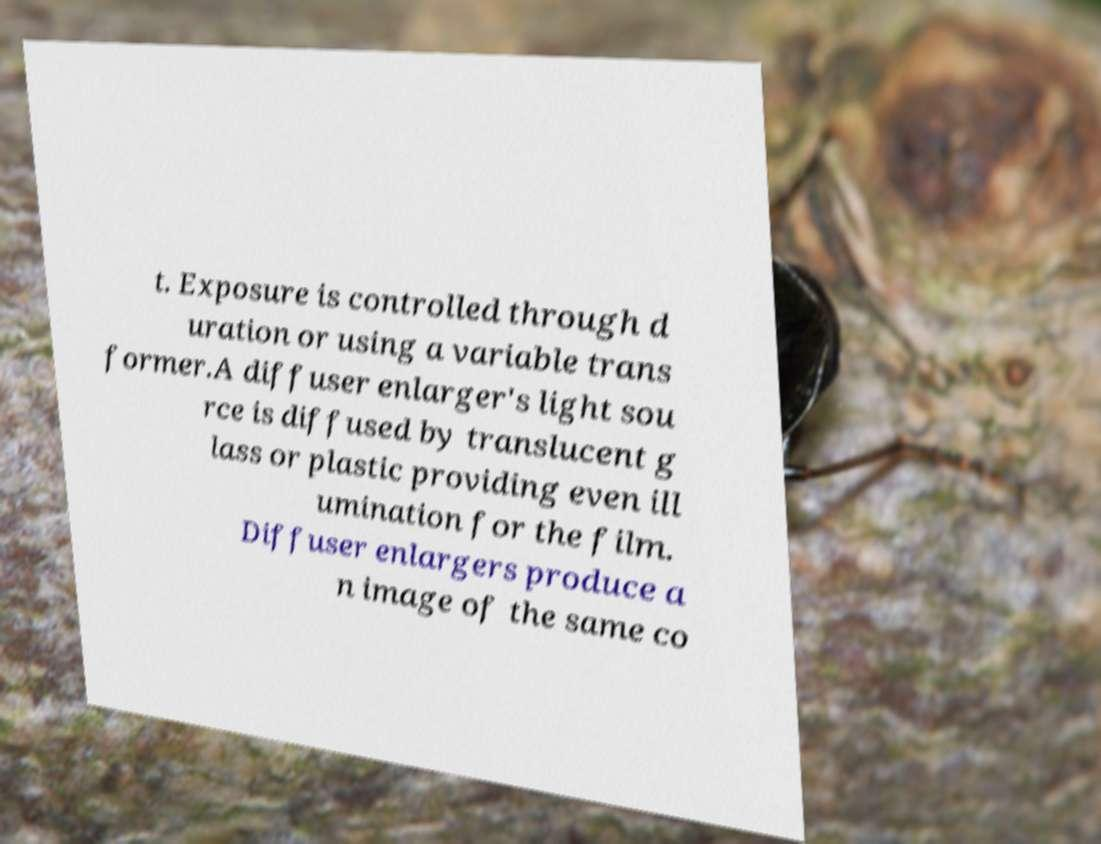I need the written content from this picture converted into text. Can you do that? t. Exposure is controlled through d uration or using a variable trans former.A diffuser enlarger's light sou rce is diffused by translucent g lass or plastic providing even ill umination for the film. Diffuser enlargers produce a n image of the same co 